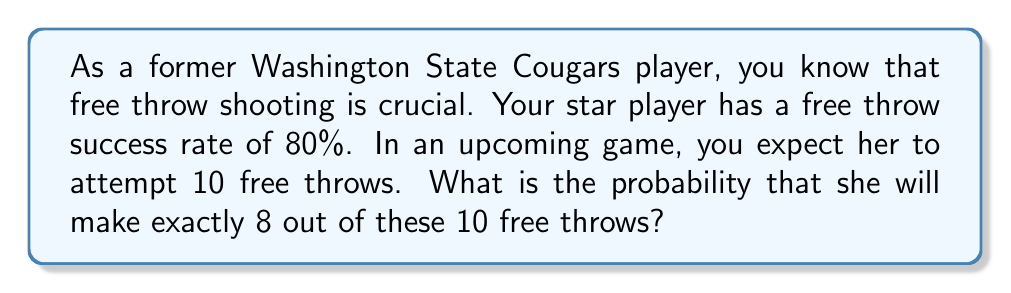Provide a solution to this math problem. Let's approach this step-by-step using the binomial probability formula:

1) This scenario follows a binomial distribution because:
   - There's a fixed number of trials (10 free throws)
   - Each trial has two possible outcomes (make or miss)
   - The probability of success is constant for each trial (80%)
   - The trials are independent

2) The binomial probability formula is:

   $$ P(X = k) = \binom{n}{k} p^k (1-p)^{n-k} $$

   Where:
   $n$ = number of trials
   $k$ = number of successes
   $p$ = probability of success on each trial

3) In this case:
   $n = 10$ (total free throws)
   $k = 8$ (successful free throws we're calculating for)
   $p = 0.80$ (80% success rate)

4) Let's calculate each part:

   $\binom{n}{k} = \binom{10}{8} = 45$ (number of ways to choose 8 out of 10)

   $p^k = 0.80^8 = 0.1678$

   $(1-p)^{n-k} = 0.20^2 = 0.04$

5) Now, let's put it all together:

   $$ P(X = 8) = 45 \times 0.1678 \times 0.04 = 0.3020 $$

6) Therefore, the probability is approximately 0.3020 or 30.20%.
Answer: 0.3020 